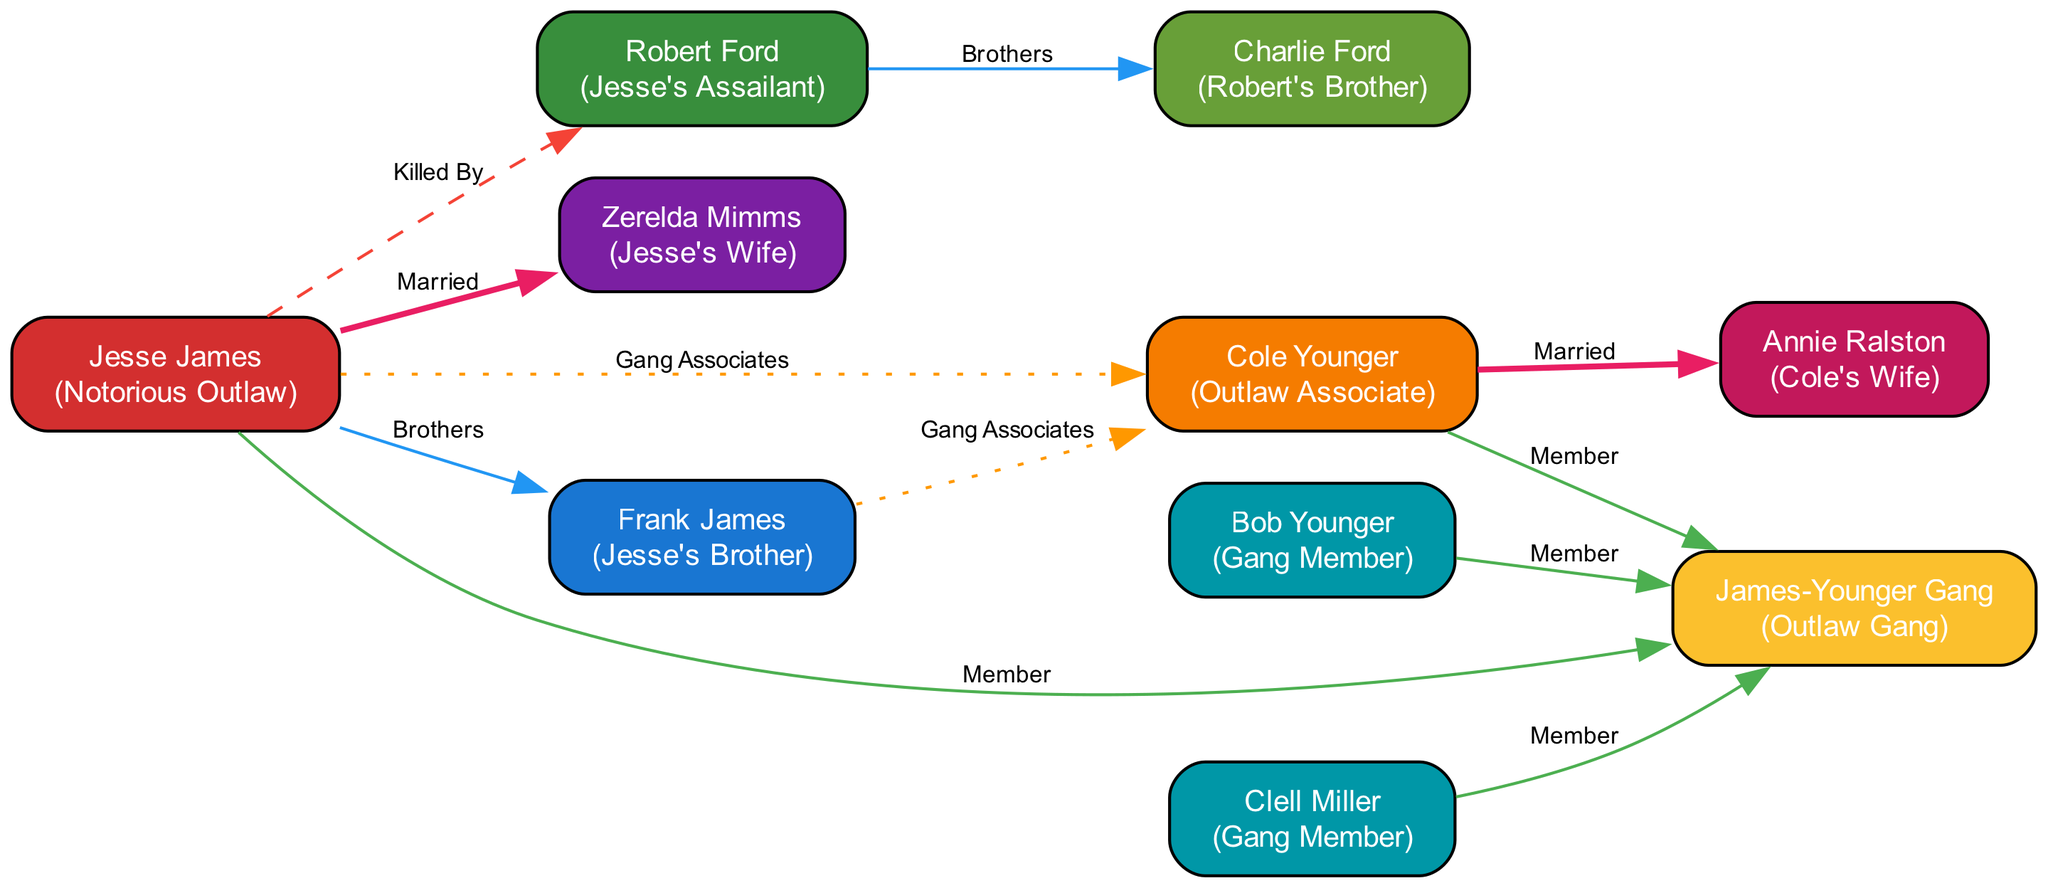What is the relationship between Jesse James and Frank James? The diagram indicates that Jesse James and Frank James are 'Brothers.' This is shown by the specific edge connecting these two nodes labeled as such.
Answer: Brothers How many nodes are present in the diagram? Counting the unique individuals or figures represented in the diagram, there are a total of 10 nodes listed.
Answer: 10 Who is Jesse James's wife? The diagram specifies that Jesse James is married to Zerelda Mimms, which is indicated by the edge connecting these two nodes labeled 'Married.'
Answer: Zerelda Mimms What role does Robert Ford play in relation to Jesse James? According to the diagram, the edge connecting Jesse James to Robert Ford is labeled 'Killed By,' indicating that Robert Ford is Jesse James's assailant.
Answer: Jesse's Assailant Which figures are associates of Jesse James in the outlaw gang? The diagram lists Frank James and Cole Younger as associates connected to Jesse James by edges labeled 'Gang Associates.' Therefore, they are considered part of his outlaw connections.
Answer: Frank James, Cole Younger How many members are part of the James-Younger Gang? The nodes connected to the 'James-Younger Gang' indicate five members: Jesse James, Frank James, Cole Younger, Clell Miller, and Bob Younger are all shown to be members of the gang.
Answer: 5 What is the relationship between Clell Miller and the James-Younger Gang? The diagram shows that Clell Miller is connected to the James-Younger Gang through an edge labeled 'Member,' indicating his affiliation with the gang.
Answer: Member Who is Charlie Ford in relation to Robert Ford? The diagram identifies Charlie Ford as Robert Ford's brother, denoted by the edge labeled 'Brothers' that connects them.
Answer: Brothers 